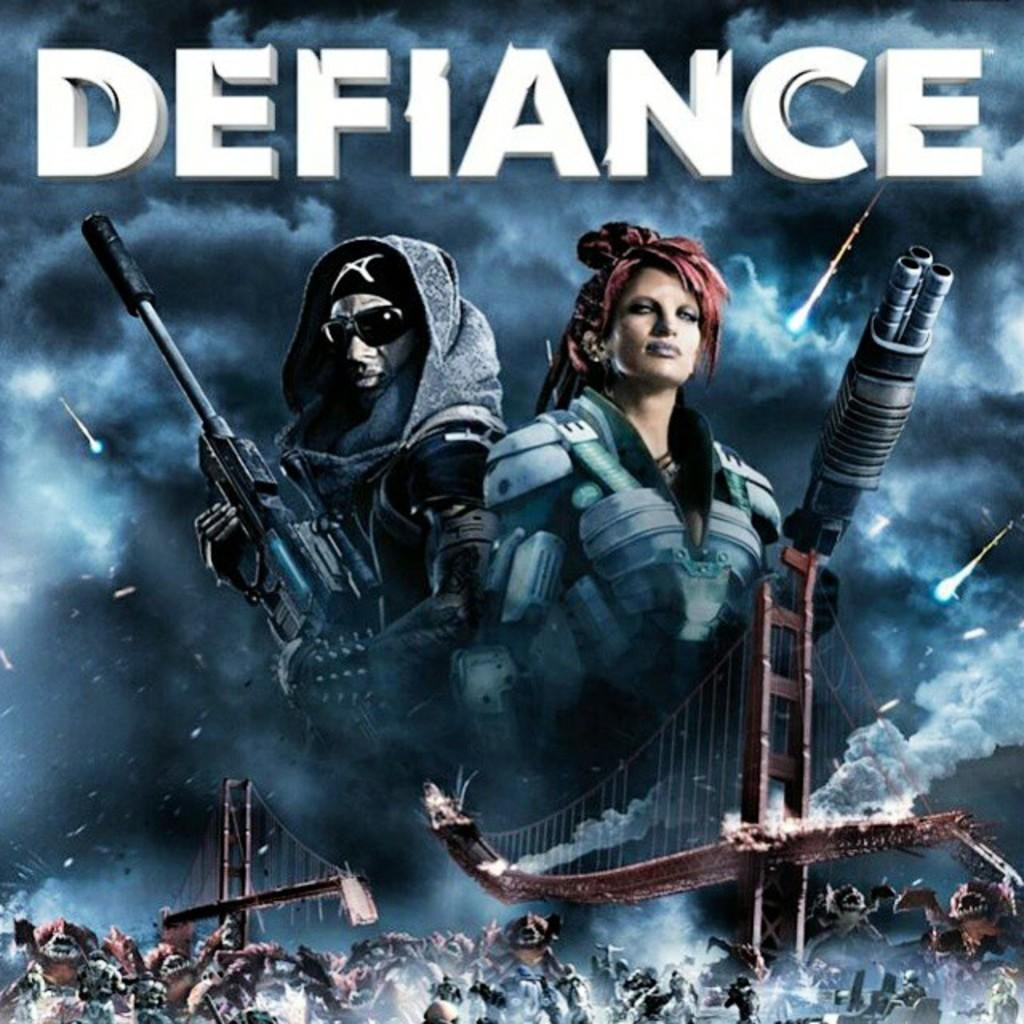<image>
Create a compact narrative representing the image presented. A movie poster for Defiance depicting a woman and man holding large guns 